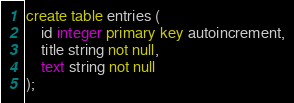<code> <loc_0><loc_0><loc_500><loc_500><_SQL_>create table entries (
    id integer primary key autoincrement,
    title string not null,
    text string not null
);
</code> 